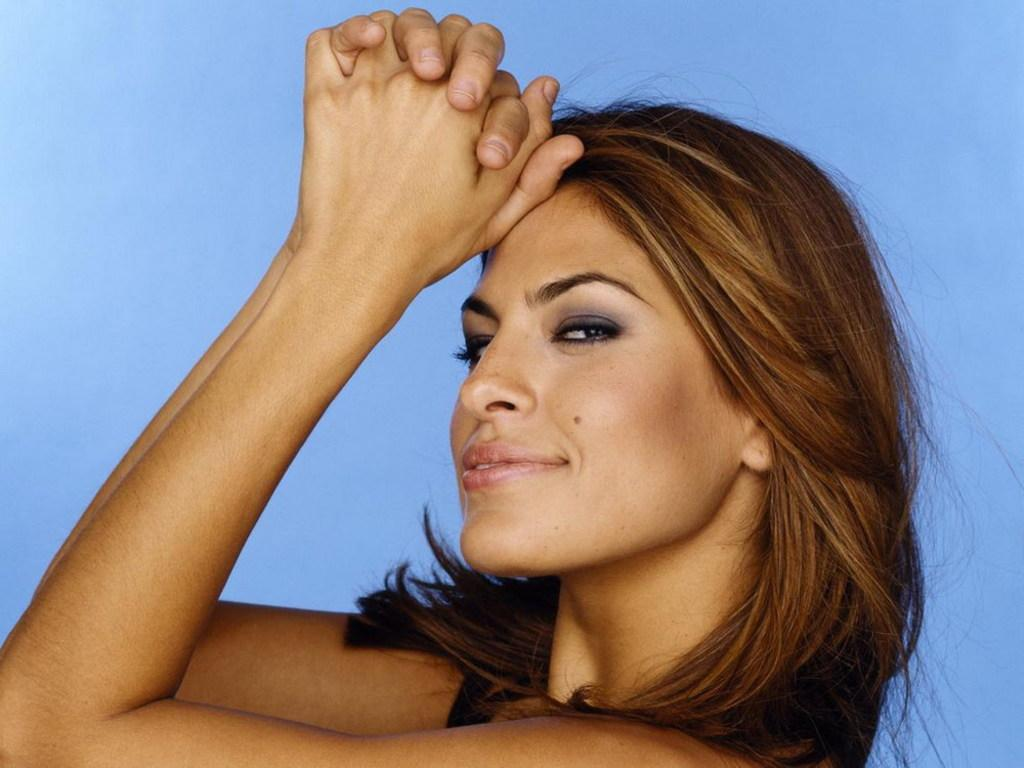Who is present in the image? There is a woman in the image. What type of bath is the woman taking in the image? There is no bath present in the image; it only features a woman. What base material is the line made of in the image? There is no line or base material present in the image. 